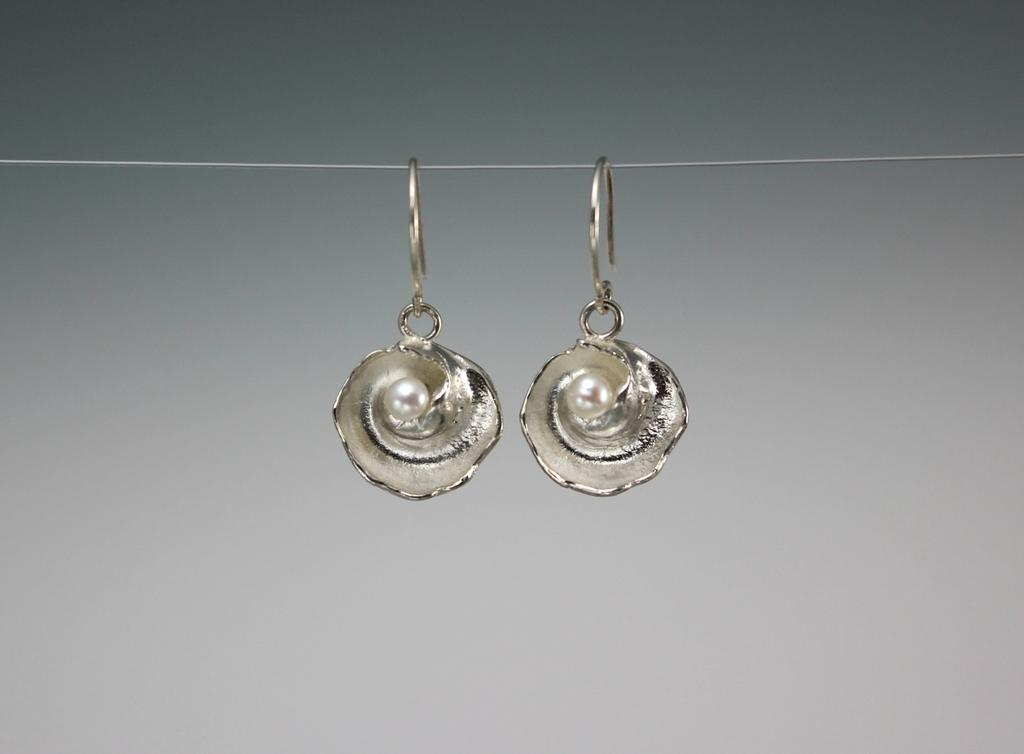What is the primary object in the image? There is a thread in the image. What is attached to the thread? Earrings are hanging from the thread. What type of jar is visible in the image? There is no jar present in the image. Can you tell me what fact the grandmother mentioned in the image? There is no mention of a grandmother or any facts in the image. 